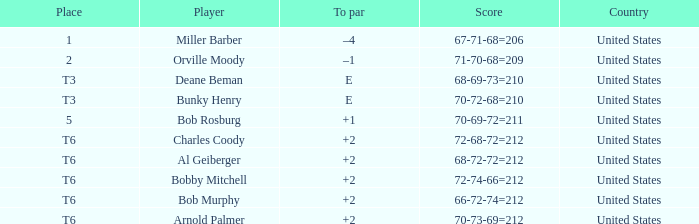What is the to par of player bunky henry? E. Can you parse all the data within this table? {'header': ['Place', 'Player', 'To par', 'Score', 'Country'], 'rows': [['1', 'Miller Barber', '–4', '67-71-68=206', 'United States'], ['2', 'Orville Moody', '–1', '71-70-68=209', 'United States'], ['T3', 'Deane Beman', 'E', '68-69-73=210', 'United States'], ['T3', 'Bunky Henry', 'E', '70-72-68=210', 'United States'], ['5', 'Bob Rosburg', '+1', '70-69-72=211', 'United States'], ['T6', 'Charles Coody', '+2', '72-68-72=212', 'United States'], ['T6', 'Al Geiberger', '+2', '68-72-72=212', 'United States'], ['T6', 'Bobby Mitchell', '+2', '72-74-66=212', 'United States'], ['T6', 'Bob Murphy', '+2', '66-72-74=212', 'United States'], ['T6', 'Arnold Palmer', '+2', '70-73-69=212', 'United States']]} 